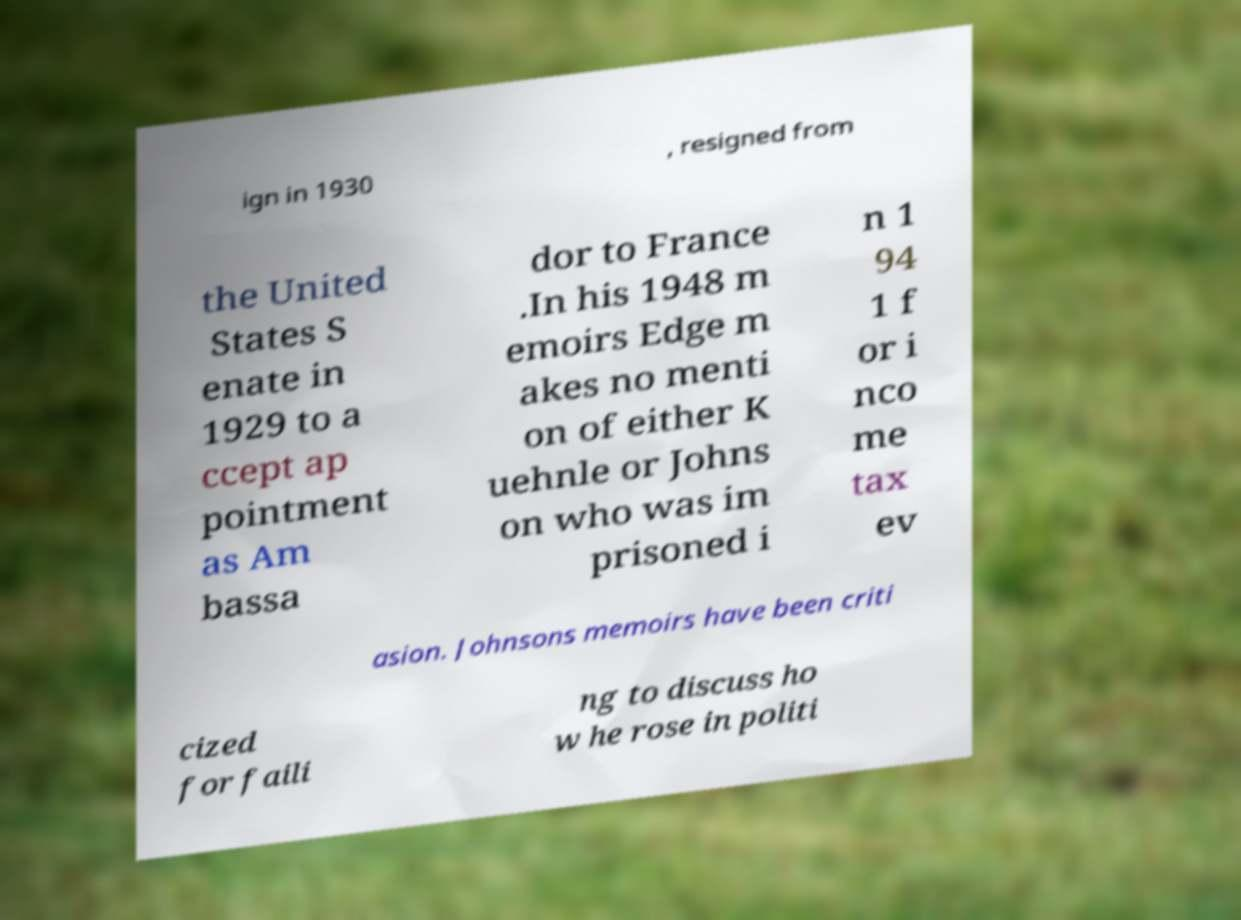Could you assist in decoding the text presented in this image and type it out clearly? ign in 1930 , resigned from the United States S enate in 1929 to a ccept ap pointment as Am bassa dor to France .In his 1948 m emoirs Edge m akes no menti on of either K uehnle or Johns on who was im prisoned i n 1 94 1 f or i nco me tax ev asion. Johnsons memoirs have been criti cized for faili ng to discuss ho w he rose in politi 